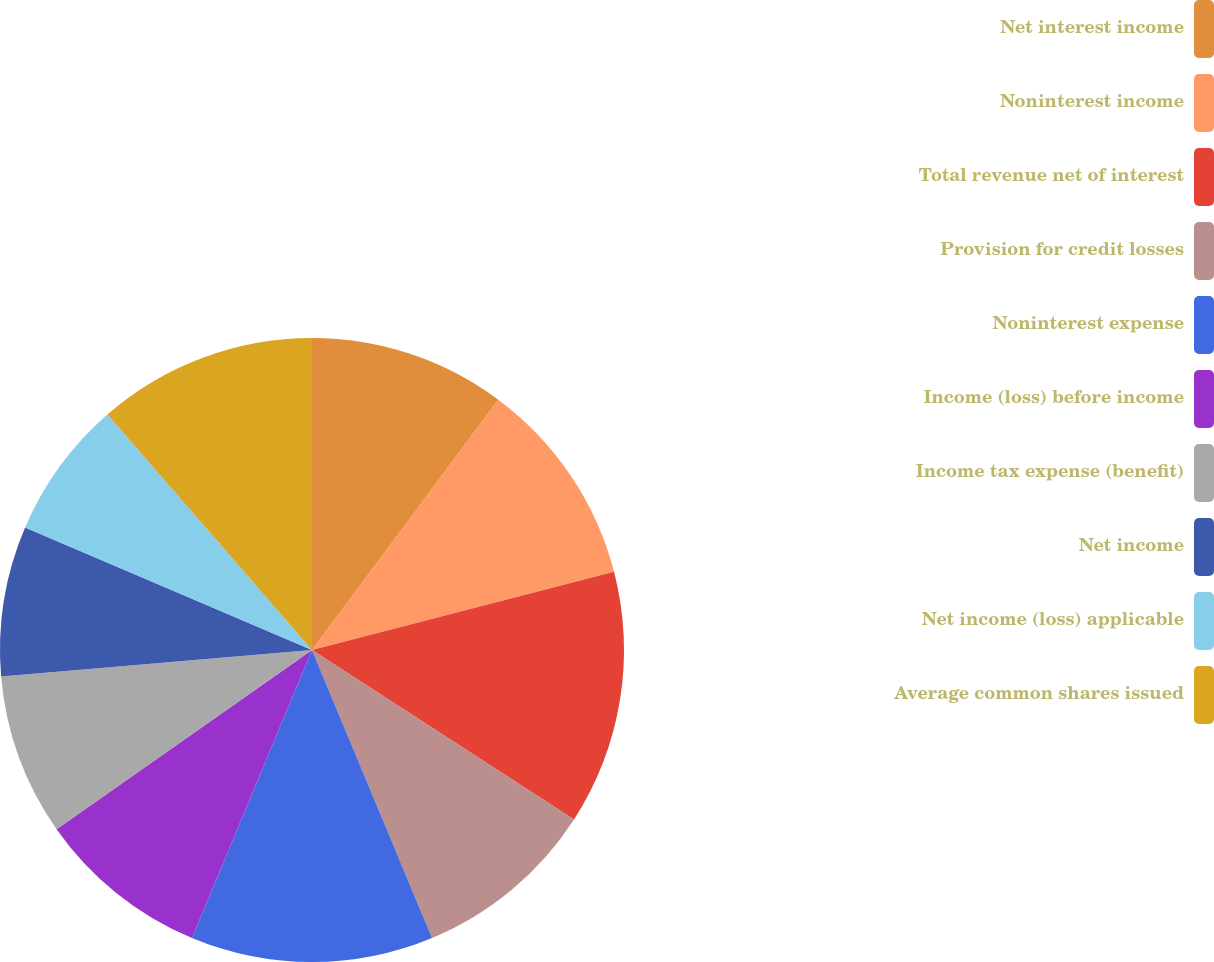Convert chart. <chart><loc_0><loc_0><loc_500><loc_500><pie_chart><fcel>Net interest income<fcel>Noninterest income<fcel>Total revenue net of interest<fcel>Provision for credit losses<fcel>Noninterest expense<fcel>Income (loss) before income<fcel>Income tax expense (benefit)<fcel>Net income<fcel>Net income (loss) applicable<fcel>Average common shares issued<nl><fcel>10.18%<fcel>10.78%<fcel>13.17%<fcel>9.58%<fcel>12.57%<fcel>8.98%<fcel>8.38%<fcel>7.78%<fcel>7.19%<fcel>11.38%<nl></chart> 